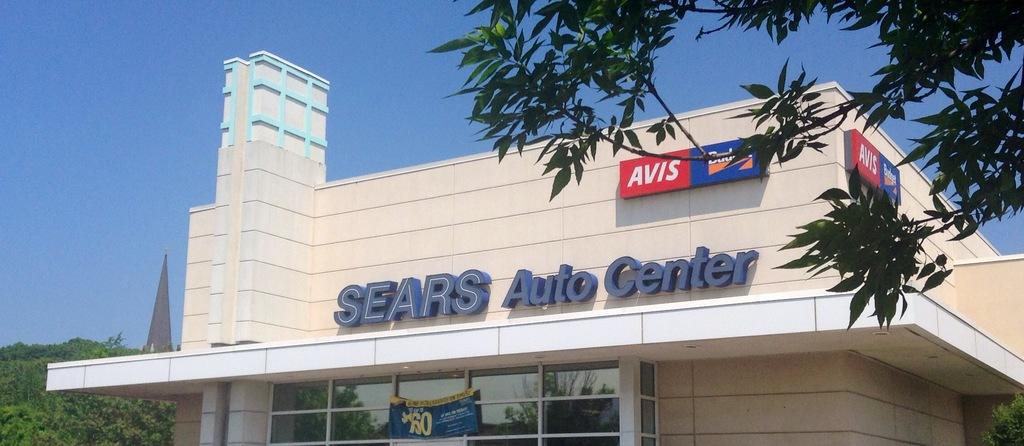What kind of activities goes on in there?
Keep it short and to the point. Auto repair. Sears auto center?
Provide a short and direct response. Yes. 